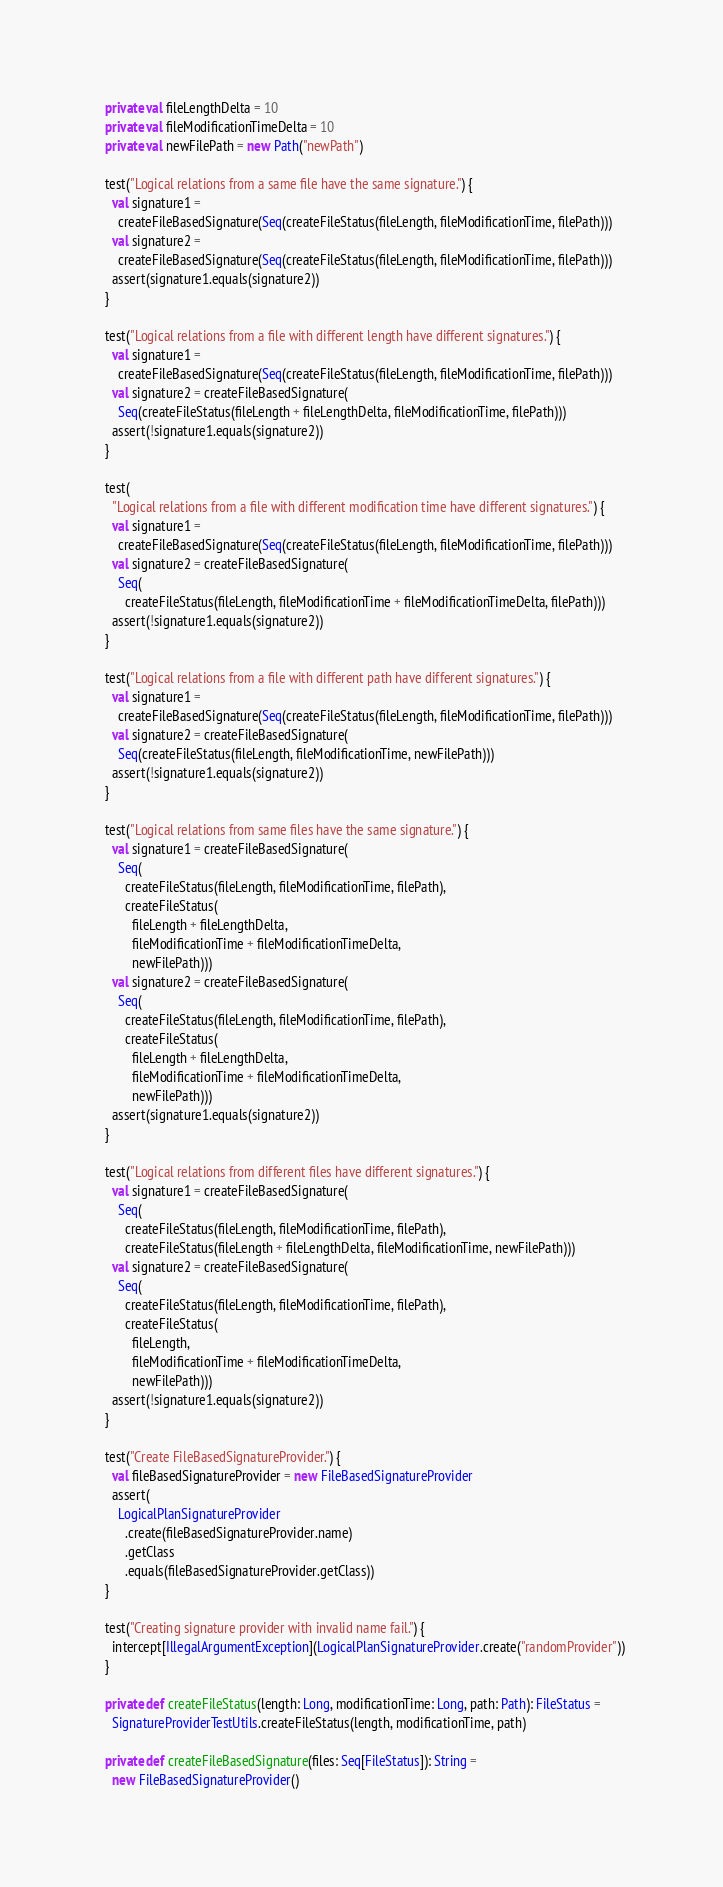Convert code to text. <code><loc_0><loc_0><loc_500><loc_500><_Scala_>  private val fileLengthDelta = 10
  private val fileModificationTimeDelta = 10
  private val newFilePath = new Path("newPath")

  test("Logical relations from a same file have the same signature.") {
    val signature1 =
      createFileBasedSignature(Seq(createFileStatus(fileLength, fileModificationTime, filePath)))
    val signature2 =
      createFileBasedSignature(Seq(createFileStatus(fileLength, fileModificationTime, filePath)))
    assert(signature1.equals(signature2))
  }

  test("Logical relations from a file with different length have different signatures.") {
    val signature1 =
      createFileBasedSignature(Seq(createFileStatus(fileLength, fileModificationTime, filePath)))
    val signature2 = createFileBasedSignature(
      Seq(createFileStatus(fileLength + fileLengthDelta, fileModificationTime, filePath)))
    assert(!signature1.equals(signature2))
  }

  test(
    "Logical relations from a file with different modification time have different signatures.") {
    val signature1 =
      createFileBasedSignature(Seq(createFileStatus(fileLength, fileModificationTime, filePath)))
    val signature2 = createFileBasedSignature(
      Seq(
        createFileStatus(fileLength, fileModificationTime + fileModificationTimeDelta, filePath)))
    assert(!signature1.equals(signature2))
  }

  test("Logical relations from a file with different path have different signatures.") {
    val signature1 =
      createFileBasedSignature(Seq(createFileStatus(fileLength, fileModificationTime, filePath)))
    val signature2 = createFileBasedSignature(
      Seq(createFileStatus(fileLength, fileModificationTime, newFilePath)))
    assert(!signature1.equals(signature2))
  }

  test("Logical relations from same files have the same signature.") {
    val signature1 = createFileBasedSignature(
      Seq(
        createFileStatus(fileLength, fileModificationTime, filePath),
        createFileStatus(
          fileLength + fileLengthDelta,
          fileModificationTime + fileModificationTimeDelta,
          newFilePath)))
    val signature2 = createFileBasedSignature(
      Seq(
        createFileStatus(fileLength, fileModificationTime, filePath),
        createFileStatus(
          fileLength + fileLengthDelta,
          fileModificationTime + fileModificationTimeDelta,
          newFilePath)))
    assert(signature1.equals(signature2))
  }

  test("Logical relations from different files have different signatures.") {
    val signature1 = createFileBasedSignature(
      Seq(
        createFileStatus(fileLength, fileModificationTime, filePath),
        createFileStatus(fileLength + fileLengthDelta, fileModificationTime, newFilePath)))
    val signature2 = createFileBasedSignature(
      Seq(
        createFileStatus(fileLength, fileModificationTime, filePath),
        createFileStatus(
          fileLength,
          fileModificationTime + fileModificationTimeDelta,
          newFilePath)))
    assert(!signature1.equals(signature2))
  }

  test("Create FileBasedSignatureProvider.") {
    val fileBasedSignatureProvider = new FileBasedSignatureProvider
    assert(
      LogicalPlanSignatureProvider
        .create(fileBasedSignatureProvider.name)
        .getClass
        .equals(fileBasedSignatureProvider.getClass))
  }

  test("Creating signature provider with invalid name fail.") {
    intercept[IllegalArgumentException](LogicalPlanSignatureProvider.create("randomProvider"))
  }

  private def createFileStatus(length: Long, modificationTime: Long, path: Path): FileStatus =
    SignatureProviderTestUtils.createFileStatus(length, modificationTime, path)

  private def createFileBasedSignature(files: Seq[FileStatus]): String =
    new FileBasedSignatureProvider()</code> 